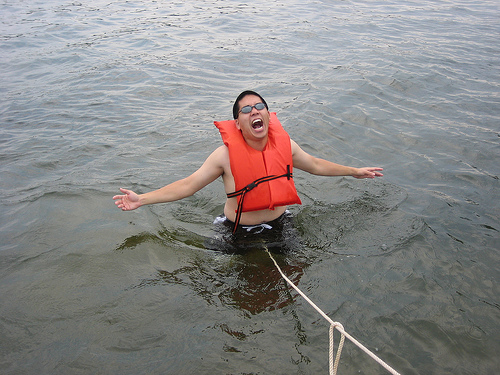<image>
Can you confirm if the life vest is on the man? Yes. Looking at the image, I can see the life vest is positioned on top of the man, with the man providing support. Where is the life jacket in relation to the man? Is it on the man? Yes. Looking at the image, I can see the life jacket is positioned on top of the man, with the man providing support. Is there a man on the water? Yes. Looking at the image, I can see the man is positioned on top of the water, with the water providing support. 